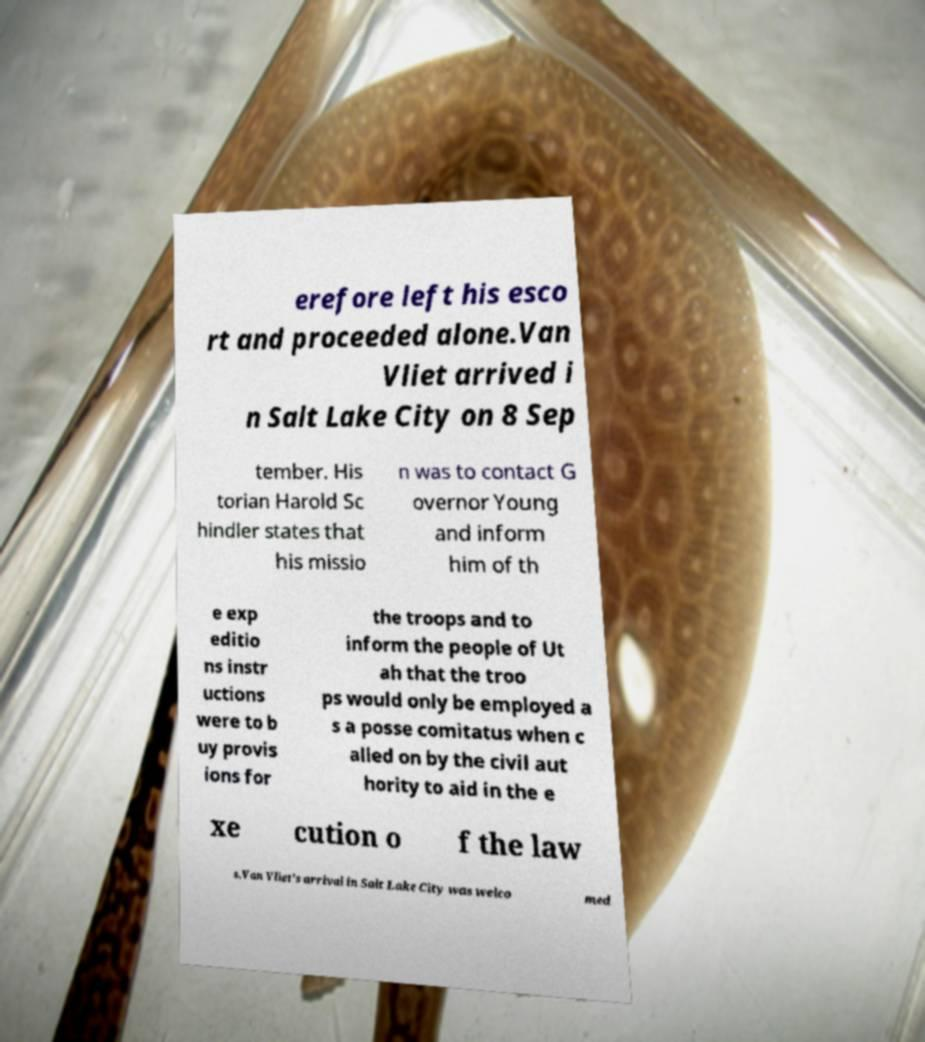Can you accurately transcribe the text from the provided image for me? erefore left his esco rt and proceeded alone.Van Vliet arrived i n Salt Lake City on 8 Sep tember. His torian Harold Sc hindler states that his missio n was to contact G overnor Young and inform him of th e exp editio ns instr uctions were to b uy provis ions for the troops and to inform the people of Ut ah that the troo ps would only be employed a s a posse comitatus when c alled on by the civil aut hority to aid in the e xe cution o f the law s.Van Vliet's arrival in Salt Lake City was welco med 